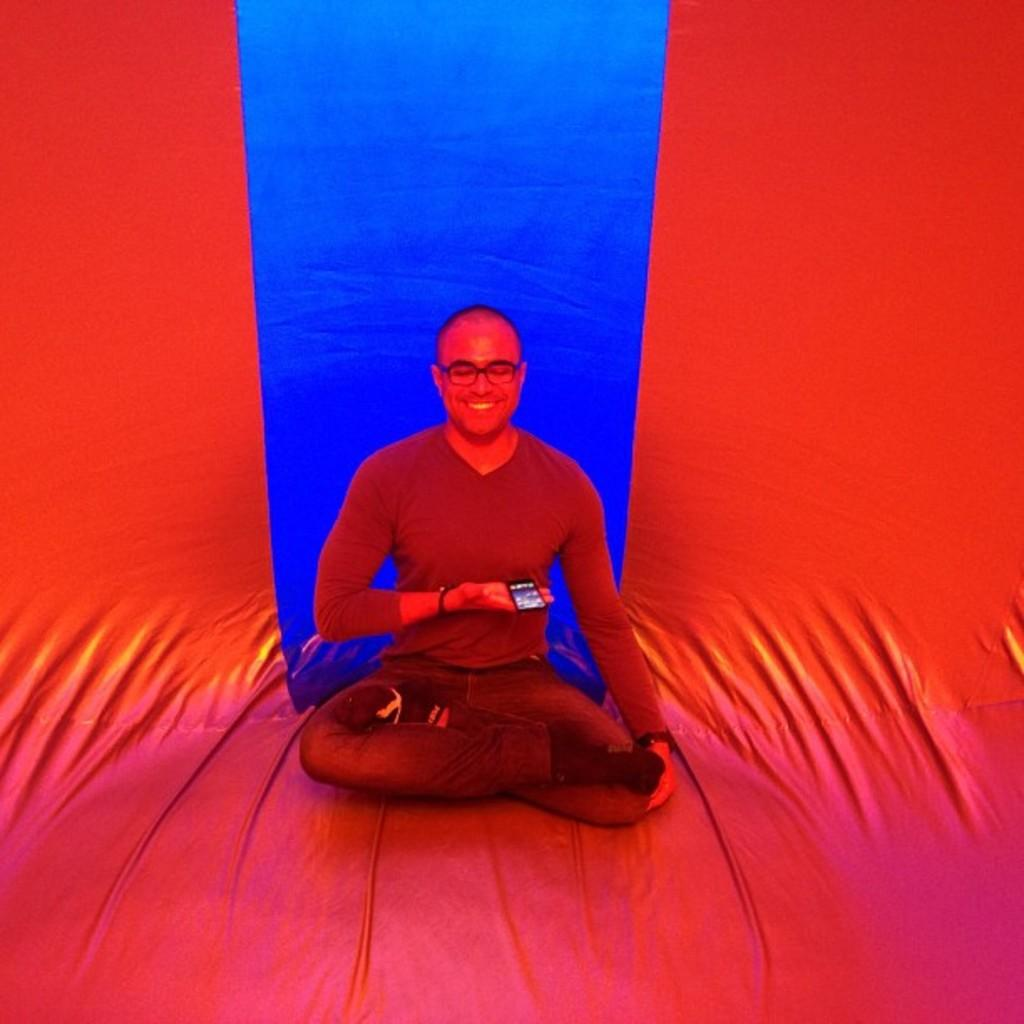What is present in the image? There is a man in the image. Can you describe the surface the man is sitting on? The man is sitting on a red and blue surface. What can be seen on the man's face? The man is wearing spectacles. What type of crate is visible on the seashore in the image? There is no crate or seashore present in the image. What shape is the shape that the man is holding in the image? The man is not holding any shape in the image. 